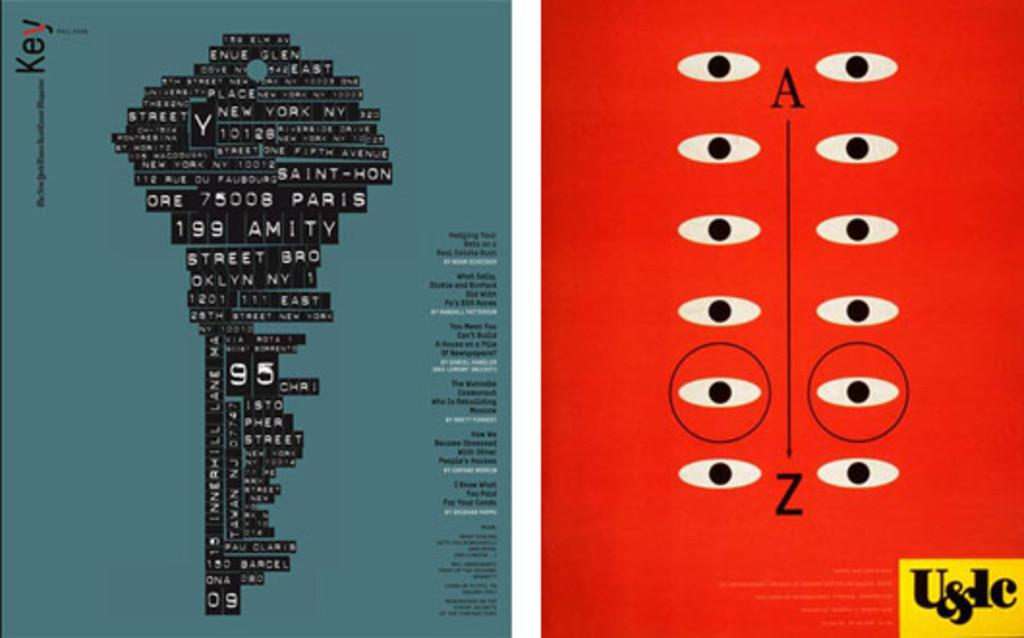<image>
Offer a succinct explanation of the picture presented. Two posters that contain Key and  U&dc with New york and eyes 